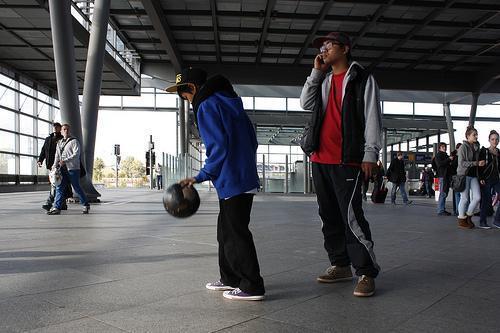How many people holding the ball?
Give a very brief answer. 1. 